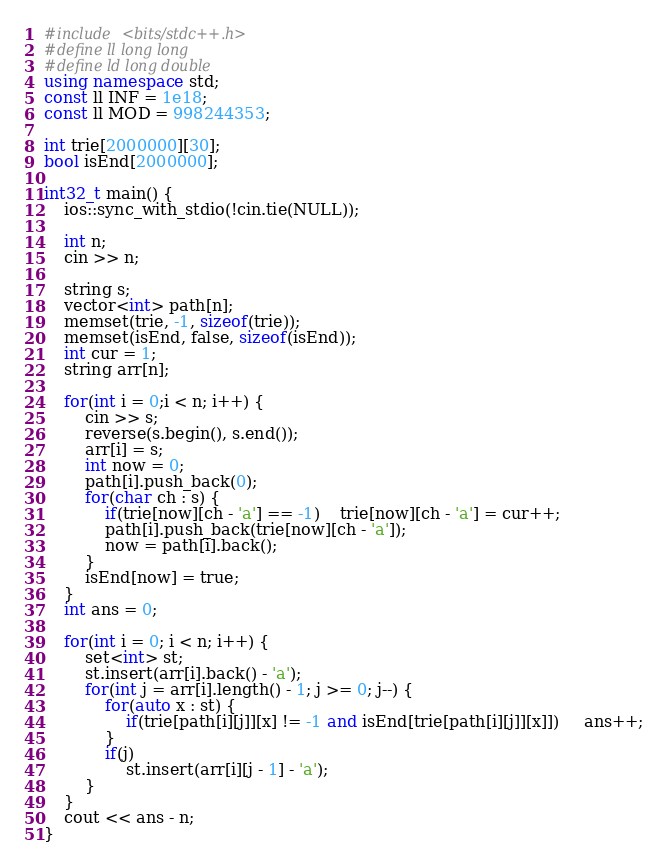<code> <loc_0><loc_0><loc_500><loc_500><_C++_>#include <bits/stdc++.h>
#define ll long long 
#define ld long double
using namespace std;
const ll INF = 1e18;
const ll MOD = 998244353;

int trie[2000000][30];
bool isEnd[2000000];

int32_t main() {
	ios::sync_with_stdio(!cin.tie(NULL));

	int n;
	cin >> n;
	
	string s;
	vector<int> path[n];
	memset(trie, -1, sizeof(trie));
	memset(isEnd, false, sizeof(isEnd));
	int cur = 1;
	string arr[n];

	for(int i = 0;i < n; i++) {
		cin >> s;
		reverse(s.begin(), s.end());
		arr[i] = s;
		int now = 0;
		path[i].push_back(0);
		for(char ch : s) {
			if(trie[now][ch - 'a'] == -1)	trie[now][ch - 'a'] = cur++;
			path[i].push_back(trie[now][ch - 'a']);
			now = path[i].back();
		}
		isEnd[now] = true;
	}
	int ans = 0;

	for(int i = 0; i < n; i++) {
		set<int> st;
		st.insert(arr[i].back() - 'a');
		for(int j = arr[i].length() - 1; j >= 0; j--) {
			for(auto x : st) {
				if(trie[path[i][j]][x] != -1 and isEnd[trie[path[i][j]][x]])	 ans++;
			}
			if(j)
				st.insert(arr[i][j - 1] - 'a');
		}
	}
	cout << ans - n;
}

</code> 